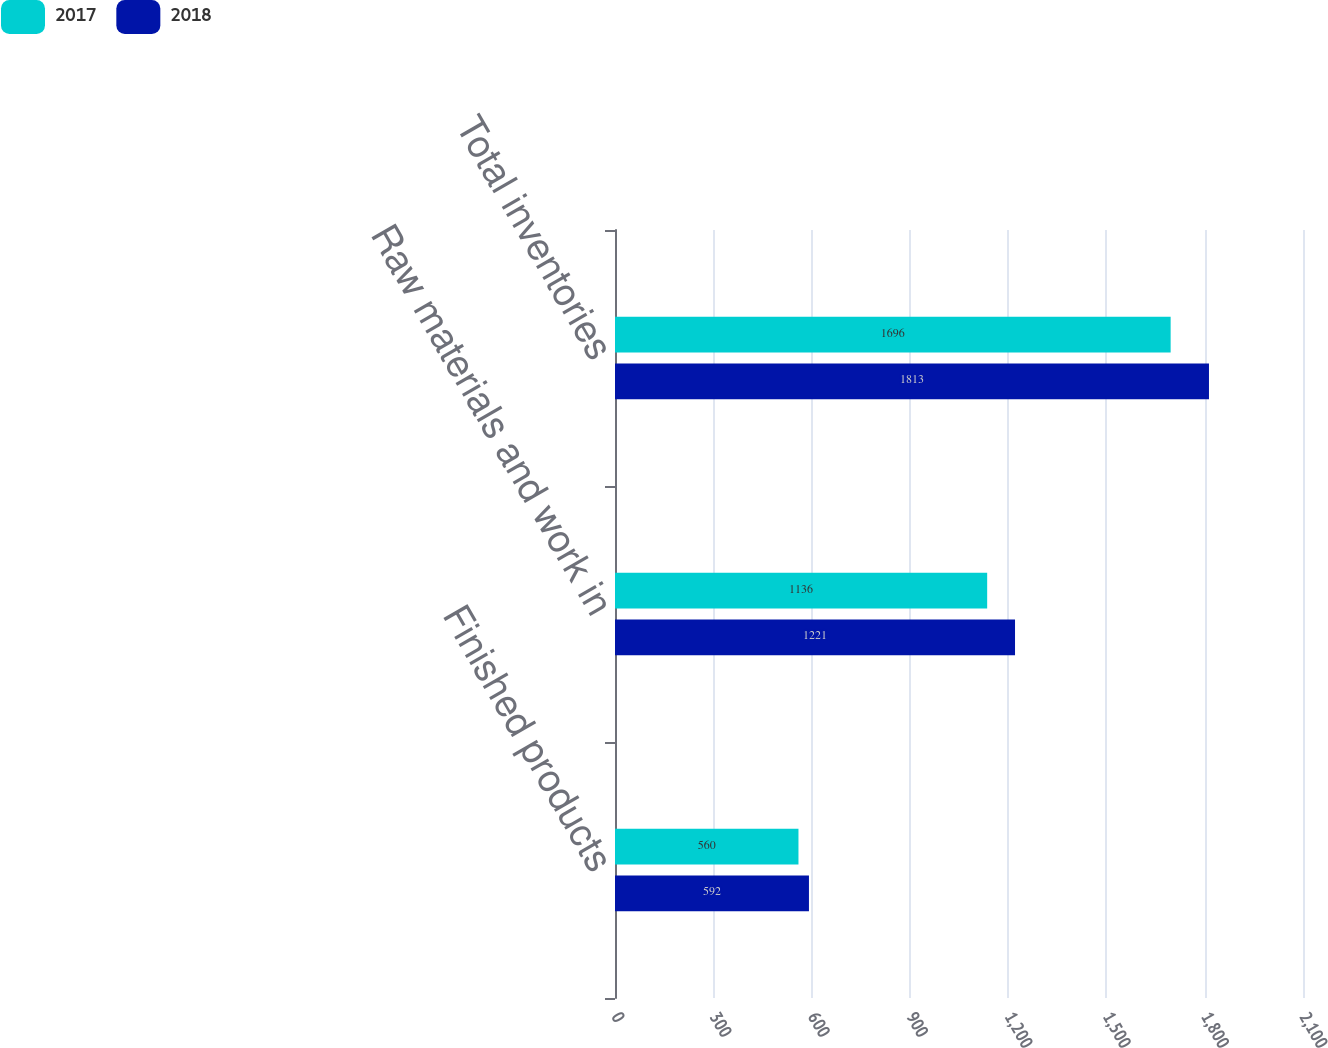<chart> <loc_0><loc_0><loc_500><loc_500><stacked_bar_chart><ecel><fcel>Finished products<fcel>Raw materials and work in<fcel>Total inventories<nl><fcel>2017<fcel>560<fcel>1136<fcel>1696<nl><fcel>2018<fcel>592<fcel>1221<fcel>1813<nl></chart> 